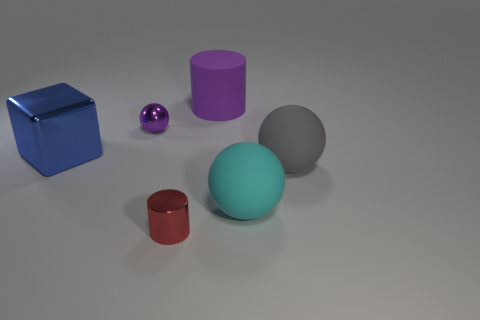How many cylinders are either small purple metal objects or large blue metal things?
Offer a very short reply. 0. The gray matte thing is what shape?
Keep it short and to the point. Sphere. There is a tiny purple object; are there any big blue blocks behind it?
Offer a very short reply. No. Is the small red cylinder made of the same material as the big ball in front of the gray matte object?
Make the answer very short. No. There is a metal object in front of the large blue metallic object; does it have the same shape as the tiny purple metallic object?
Your answer should be very brief. No. What number of other purple cylinders have the same material as the big purple cylinder?
Offer a very short reply. 0. How many objects are big things that are behind the big shiny thing or small yellow metal cubes?
Offer a terse response. 1. What is the size of the gray rubber ball?
Keep it short and to the point. Large. What material is the big thing left of the cylinder behind the red shiny cylinder made of?
Offer a very short reply. Metal. There is a sphere that is on the left side of the cyan rubber sphere; is it the same size as the matte cylinder?
Provide a succinct answer. No. 